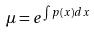<formula> <loc_0><loc_0><loc_500><loc_500>\mu = e ^ { \int p ( x ) d x }</formula> 